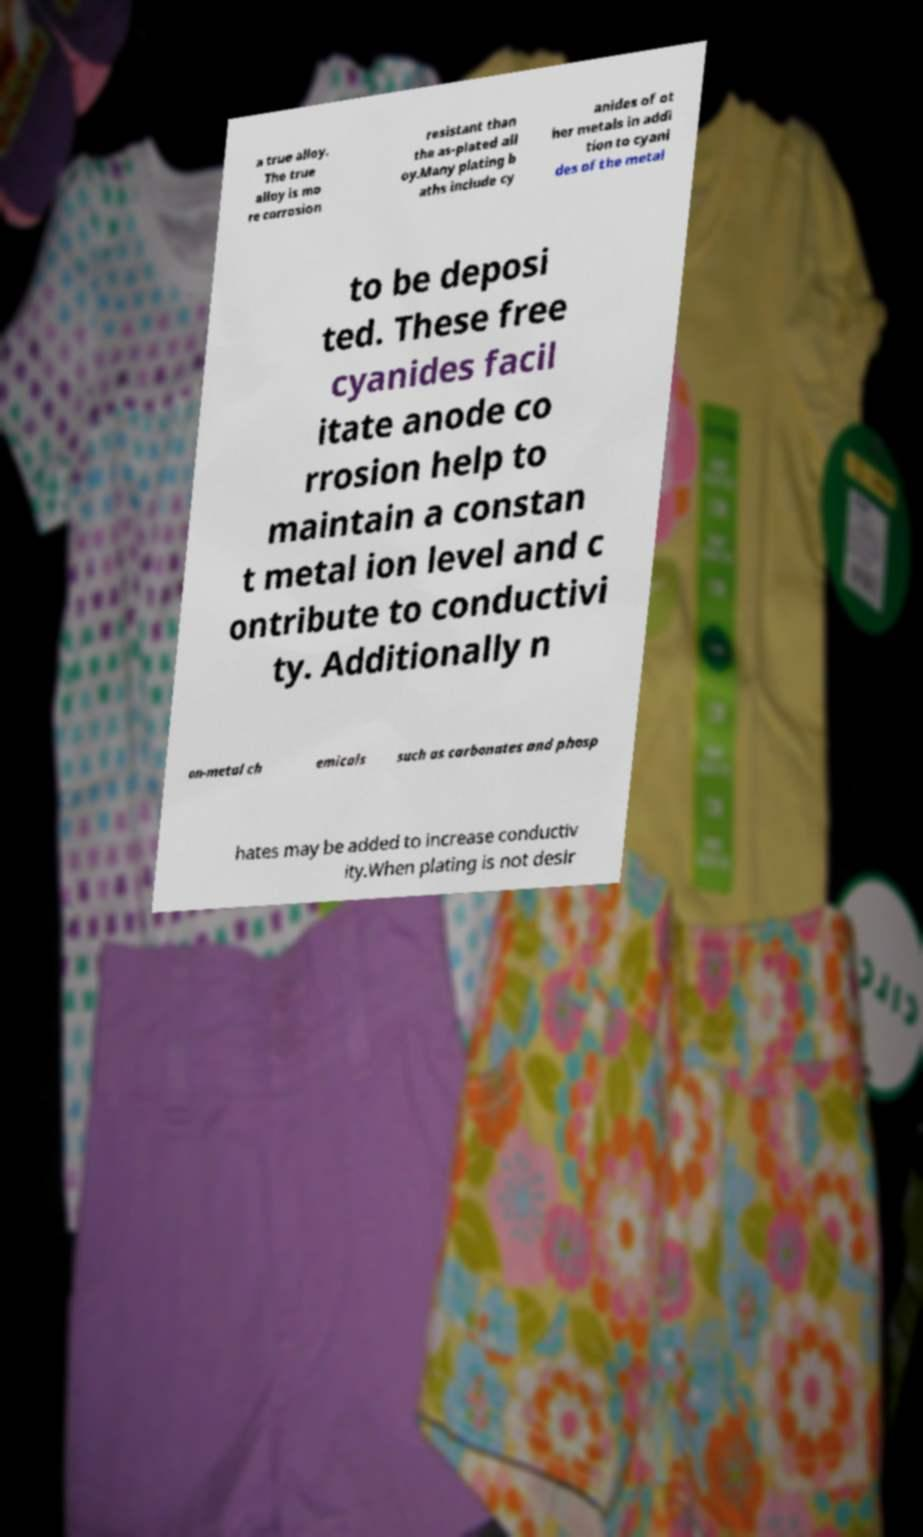What messages or text are displayed in this image? I need them in a readable, typed format. a true alloy. The true alloy is mo re corrosion resistant than the as-plated all oy.Many plating b aths include cy anides of ot her metals in addi tion to cyani des of the metal to be deposi ted. These free cyanides facil itate anode co rrosion help to maintain a constan t metal ion level and c ontribute to conductivi ty. Additionally n on-metal ch emicals such as carbonates and phosp hates may be added to increase conductiv ity.When plating is not desir 